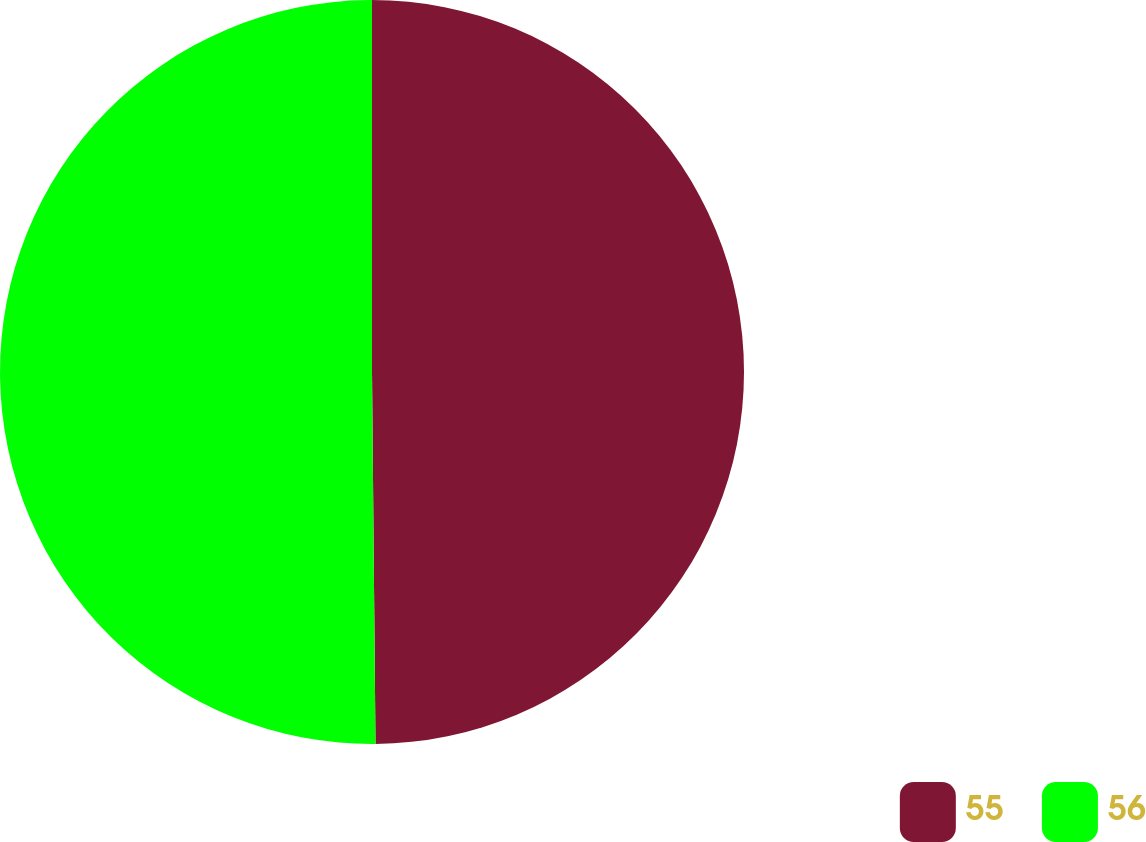Convert chart. <chart><loc_0><loc_0><loc_500><loc_500><pie_chart><fcel>55<fcel>56<nl><fcel>49.85%<fcel>50.15%<nl></chart> 